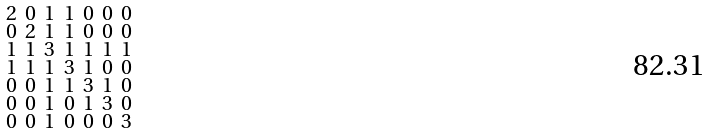Convert formula to latex. <formula><loc_0><loc_0><loc_500><loc_500>\begin{smallmatrix} 2 & 0 & 1 & 1 & 0 & 0 & 0 \\ 0 & 2 & 1 & 1 & 0 & 0 & 0 \\ 1 & 1 & 3 & 1 & 1 & 1 & 1 \\ 1 & 1 & 1 & 3 & 1 & 0 & 0 \\ 0 & 0 & 1 & 1 & 3 & 1 & 0 \\ 0 & 0 & 1 & 0 & 1 & 3 & 0 \\ 0 & 0 & 1 & 0 & 0 & 0 & 3 \end{smallmatrix}</formula> 